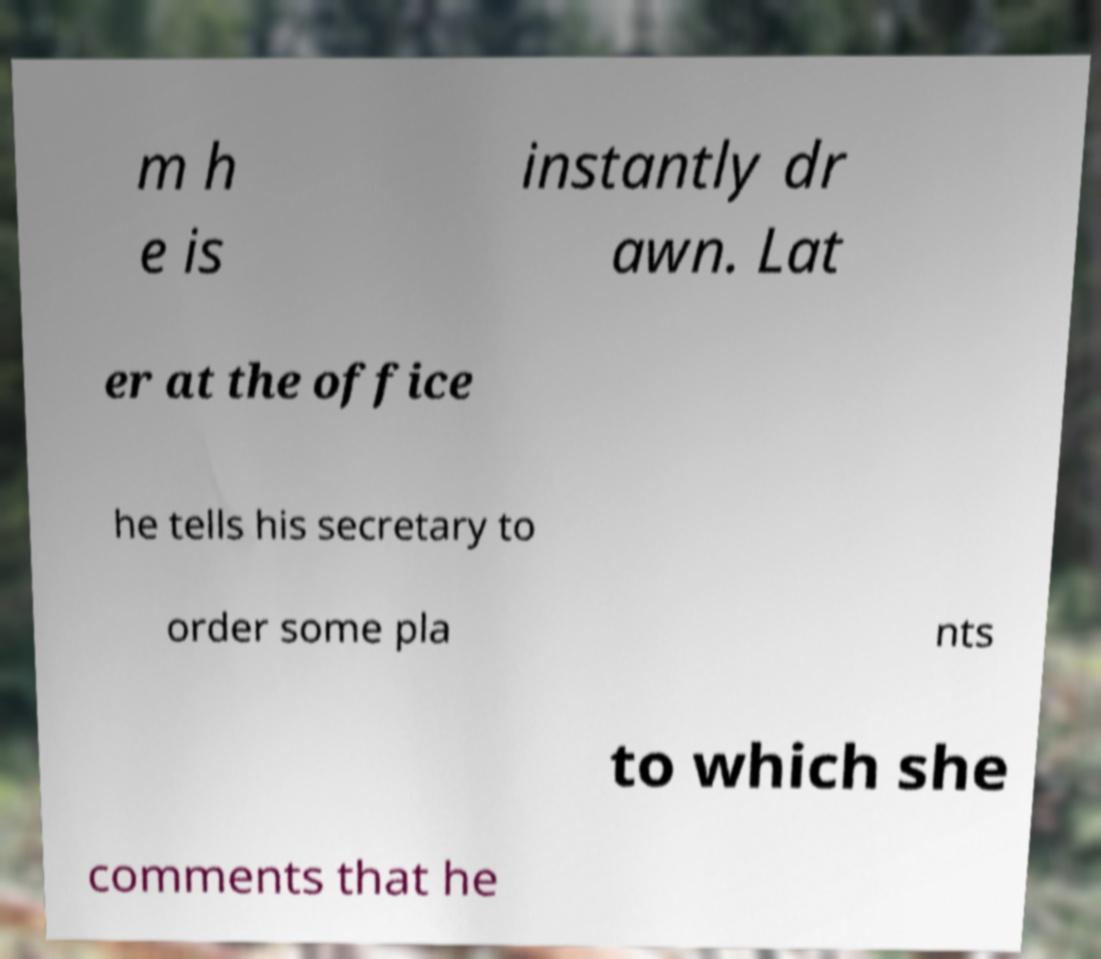Could you assist in decoding the text presented in this image and type it out clearly? m h e is instantly dr awn. Lat er at the office he tells his secretary to order some pla nts to which she comments that he 